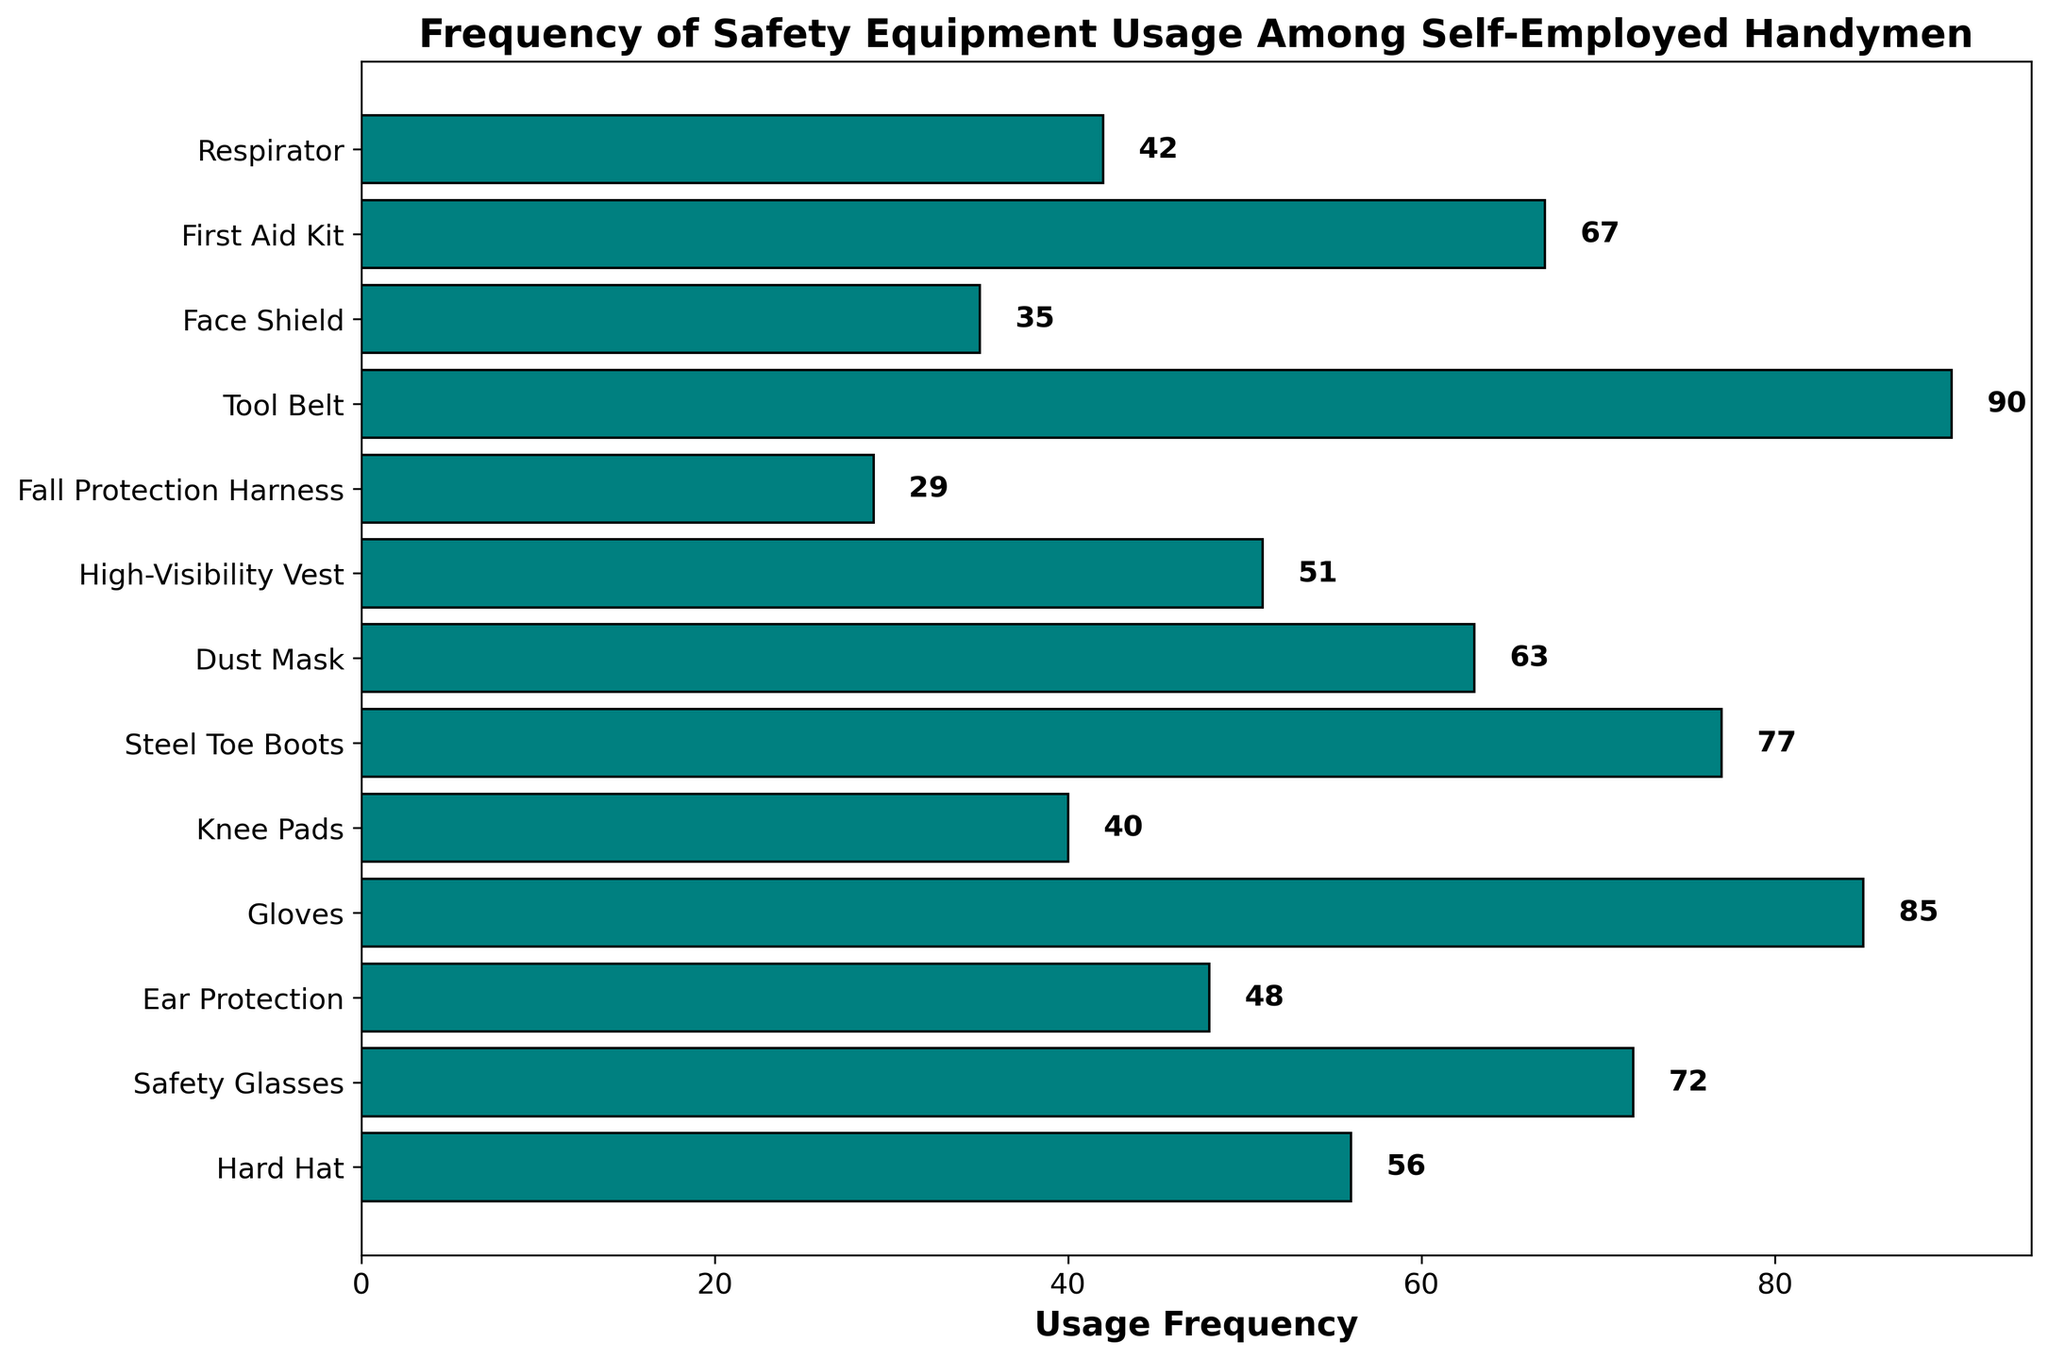Which safety equipment has the highest usage frequency? To answer this, look for the tallest bar in the plot. The equipment with the highest bar length is the most frequently used. The Tool Belt has the highest bar with a usage frequency of 90.
Answer: Tool Belt What is the total usage frequency of Hard Hat and Safety Glasses combined? Identify the usage frequencies of both Hard Hat (56) and Safety Glasses (72) from the plot, then add them together: 56 + 72 = 128.
Answer: 128 Is Ear Protection used more frequently than First Aid Kit? Compare the lengths of the bars for Ear Protection (48) and First Aid Kit (67). The bar for First Aid Kit is longer, indicating a higher usage frequency.
Answer: No Which two pieces of equipment have the closest usage frequencies? Identify the pairs of bars with the closest heights. Comparing their values, High-Visibility Vest (51) and Hard Hat (56) have a difference of 5, which is the smallest difference among all pairs.
Answer: High-Visibility Vest and Hard Hat What is the average usage frequency of Safety Glasses, Dust Mask, and Gloves? Find the usage frequencies: Safety Glasses (72), Dust Mask (63), and Gloves (85). Calculate the average: (72 + 63 + 85) / 3 = 73.33.
Answer: 73.33 Which equipment has a lower usage frequency: Steel Toe Boots or Respirator? Compare the lengths of the bars for Steel Toe Boots (77) and Respirator (42). The bar for Respirator is shorter, indicating a lower usage frequency.
Answer: Respirator How many pieces of equipment are used less frequently than Knee Pads? Identify the usage frequency of Knee Pads (40) and count the bars with usage frequencies less than 40. There are two pieces of equipment: Fall Protection Harness (29) and Face Shield (35).
Answer: 2 What is the total usage frequency of all pieces of equipment? Sum all the usage frequencies from the plot: 56 + 72 + 48 + 85 + 40 + 77 + 63 + 51 + 29 + 90 + 35 + 67 + 42 = 755.
Answer: 755 Which piece of equipment has the second highest usage frequency? Identify the lengths of all bars and find the second longest. The second longest bar corresponds to Steel Toe Boots with a usage frequency of 77.
Answer: Steel Toe Boots What's the difference in usage frequency between the most and least frequently used equipment? Identify the usage frequency of the most used (Tool Belt, 90) and least used (Fall Protection Harness, 29). Calculate the difference: 90 - 29 = 61.
Answer: 61 